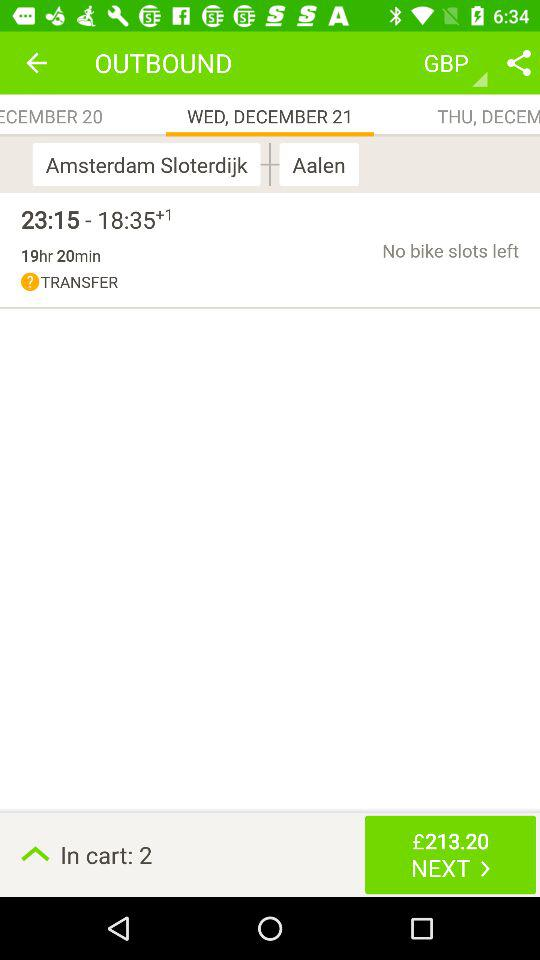What is the number of items in the cart? There are 2 items in the cart. 